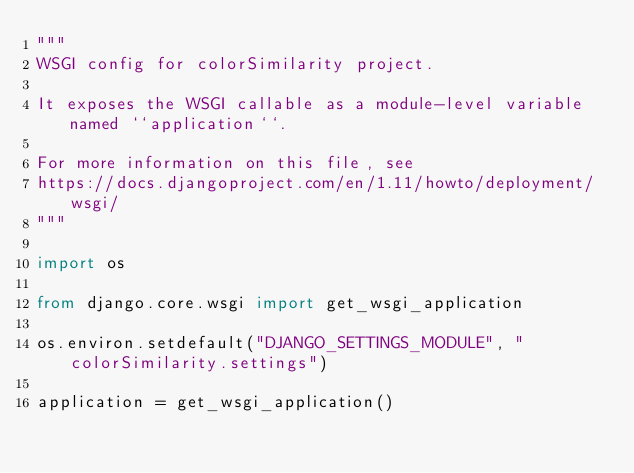Convert code to text. <code><loc_0><loc_0><loc_500><loc_500><_Python_>"""
WSGI config for colorSimilarity project.

It exposes the WSGI callable as a module-level variable named ``application``.

For more information on this file, see
https://docs.djangoproject.com/en/1.11/howto/deployment/wsgi/
"""

import os

from django.core.wsgi import get_wsgi_application

os.environ.setdefault("DJANGO_SETTINGS_MODULE", "colorSimilarity.settings")

application = get_wsgi_application()
</code> 